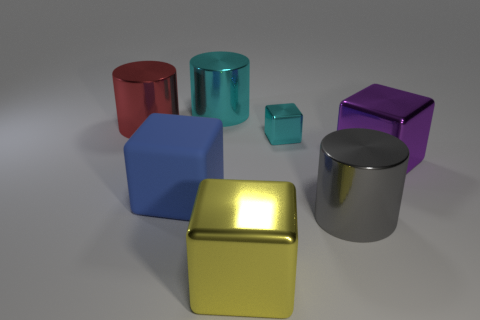Are there any other things that are the same size as the cyan metal cube?
Give a very brief answer. No. How big is the rubber object?
Your response must be concise. Large. What number of objects are either big red metallic cylinders or big metal objects behind the big blue object?
Give a very brief answer. 3. What number of big purple things are behind the big cylinder that is in front of the cube to the right of the gray object?
Make the answer very short. 1. There is a thing that is the same color as the tiny shiny cube; what is it made of?
Your response must be concise. Metal. What number of red objects are there?
Offer a very short reply. 1. There is a metal cylinder that is in front of the rubber cube; is it the same size as the small cyan thing?
Offer a terse response. No. How many rubber objects are cubes or yellow objects?
Make the answer very short. 1. There is a cylinder that is in front of the big blue block; how many large metallic objects are to the right of it?
Your answer should be very brief. 1. What shape is the big object that is both on the right side of the yellow shiny block and left of the large purple shiny object?
Your answer should be compact. Cylinder. 